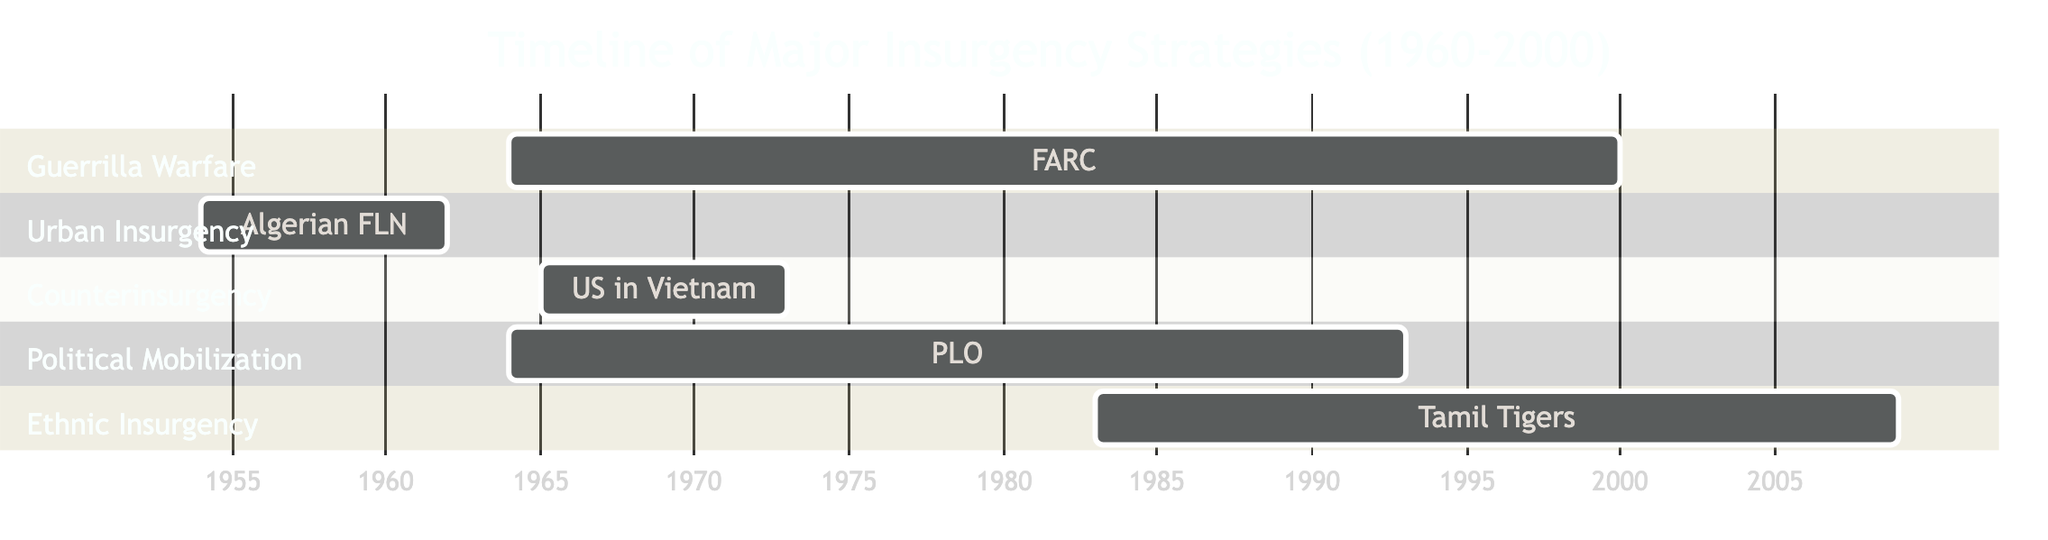What is the duration of the FARC's guerrilla warfare strategy? The FARC's guerrilla warfare strategy spans from 1964 to 2000. To calculate the duration, we subtract the start year from the end year: 2000 - 1964 = 36 years.
Answer: 36 years Which group's strategy is represented in the urban insurgency section? The urban insurgency section corresponds to the Algerian National Liberation Front (FLN), as labeled in the Gantt chart.
Answer: Algerian National Liberation Front What is the starting year of the Tamil Tigers' ethnic insurgency? According to the Gantt chart, the Tamil Tigers (LTTE) began their ethnic insurgency in 1983, as indicated in the diagram.
Answer: 1983 How many different strategies are depicted in the diagram? By counting each unique section in the Gantt chart, we find there are five strategies: guerrilla warfare, urban insurgency, counterinsurgency, political mobilization, and ethnic insurgency.
Answer: Five What is the last year the Palestine Liberation Organization (PLO) implemented their strategy? The PLO's strategy of political mobilization and propaganda lasted until 1993, as indicated in the timeline of the Gantt chart.
Answer: 1993 Which strategy overlaps with the US counterinsurgency operations? To determine the overlap, we look at the timeline of the US counterinsurgency operations, which are from 1965 to 1973, and find that the PLO's strategy begins in 1964 and ends in 1993, indicating overlap with both strategies during the years 1965 to 1973.
Answer: Political Mobilization What are the years of the Algerian National Liberation Front (FLN) strategy? The Gantt chart shows that the FLN's urban insurgency strategy starts in 1954 and ends in 1962, as represented in the section of the diagram.
Answer: 1954 to 1962 Which insurgent group used guerrilla warfare for the longest duration? Upon reviewing the timelines presented in the Gantt chart, the FARC's guerilla warfare strategy lasts from 1964 to 2000, totaling 36 years, which is longer than any other group's strategy.
Answer: FARC What year did the United States conduct counterinsurgency operations? The Gantt chart details that the United States conducted counterinsurgency operations in Vietnam from 1965 to 1973, which can be found in that section of the diagram.
Answer: 1965 to 1973 